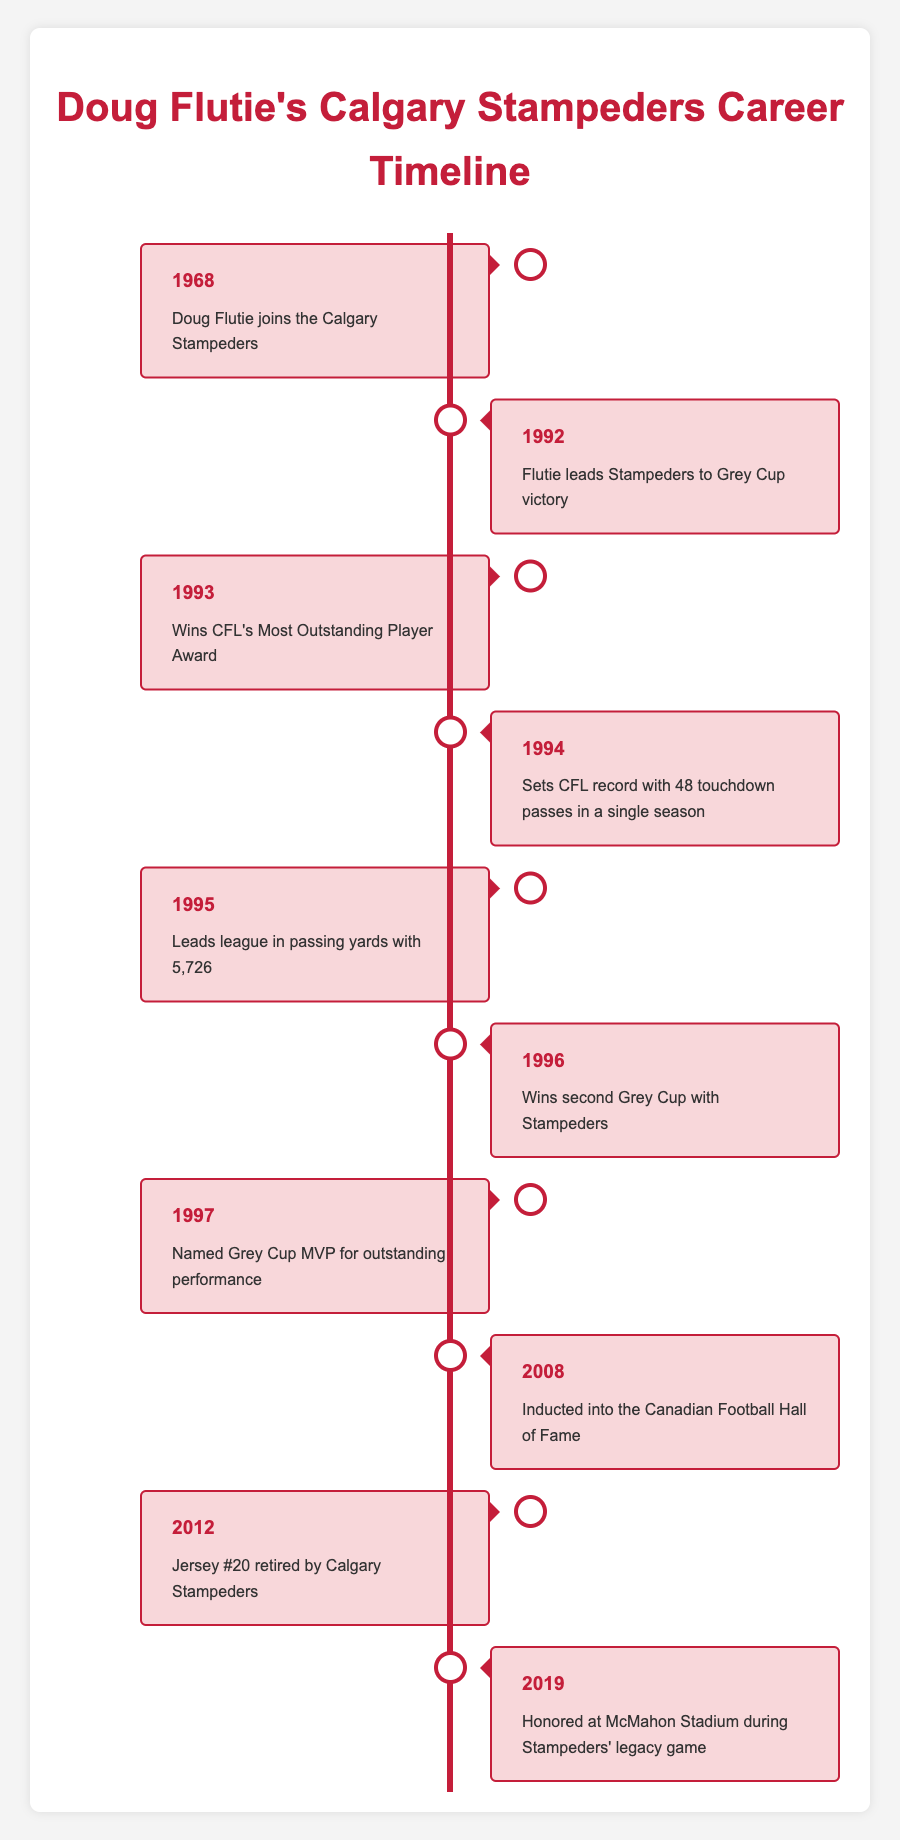What year did Doug Flutie join the Calgary Stampeders? According to the timeline, Doug Flutie joined the Calgary Stampeders in 1968, as indicated in the first event listed.
Answer: 1968 How many Grey Cups did Doug Flutie win while playing for the Stampeders? The timeline shows that Flutie won two Grey Cups with the Stampeders—once in 1992 and again in 1996.
Answer: 2 What significant achievement did Flutie accomplish in 1994? In 1994, Doug Flutie set a CFL record with 48 touchdown passes in a single season, as detailed in the timeline for that year.
Answer: 48 touchdown passes Was Doug Flutie named Grey Cup MVP during his career? Yes, the timeline notes that he was named Grey Cup MVP in 1997 for his outstanding performance during the game.
Answer: Yes In what years did Flutie receive major individual awards and honors after leaving the Stampeders? Major individual honors include winning the CFL's Most Outstanding Player Award in 1993, being inducted into the Canadian Football Hall of Fame in 2008, and having his jersey #20 retired in 2012.
Answer: 1993, 2008, 2012 What is the time span of Doug Flutie's professional career with the Calgary Stampeders? Doug Flutie's career with the Calgary Stampeders spanned from 1968 to 1996, which gives us a total of 28 years considering his joining and last noted Grey Cup win.
Answer: 28 years How many events in total are listed in the timeline? The timeline contains a total of 10 distinct events documenting key milestones in Doug Flutie's career with the Stampeders.
Answer: 10 What year did Doug Flutie lead the Stampeders to a Grey Cup victory? According to the timeline, Doug Flutie led the Stampeders to a Grey Cup victory in 1992, which is clearly marked in the respective event.
Answer: 1992 Did Flutie lead the league in passing yards in 1995? Yes, the timeline indicates that in 1995 Flutie led the league in passing yards with a total of 5,726 yards.
Answer: Yes What event happened most recently in the timeline? The most recent event listed in the timeline is from 2019 when Doug Flutie was honored at McMahon Stadium during the Stampeders' legacy game.
Answer: 2019 